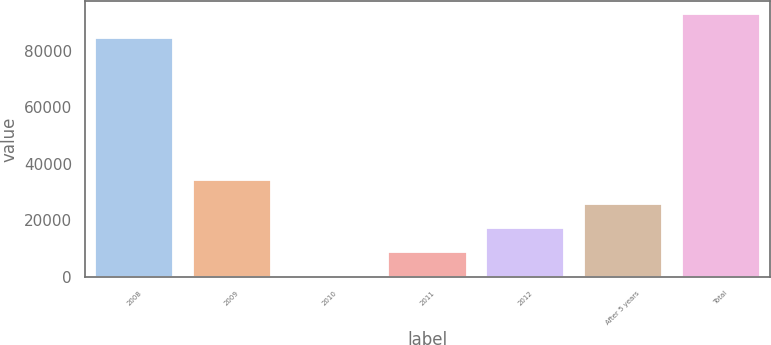Convert chart. <chart><loc_0><loc_0><loc_500><loc_500><bar_chart><fcel>2008<fcel>2009<fcel>2010<fcel>2011<fcel>2012<fcel>After 5 years<fcel>Total<nl><fcel>84260<fcel>34154.8<fcel>80<fcel>8598.7<fcel>17117.4<fcel>25636.1<fcel>92778.7<nl></chart> 